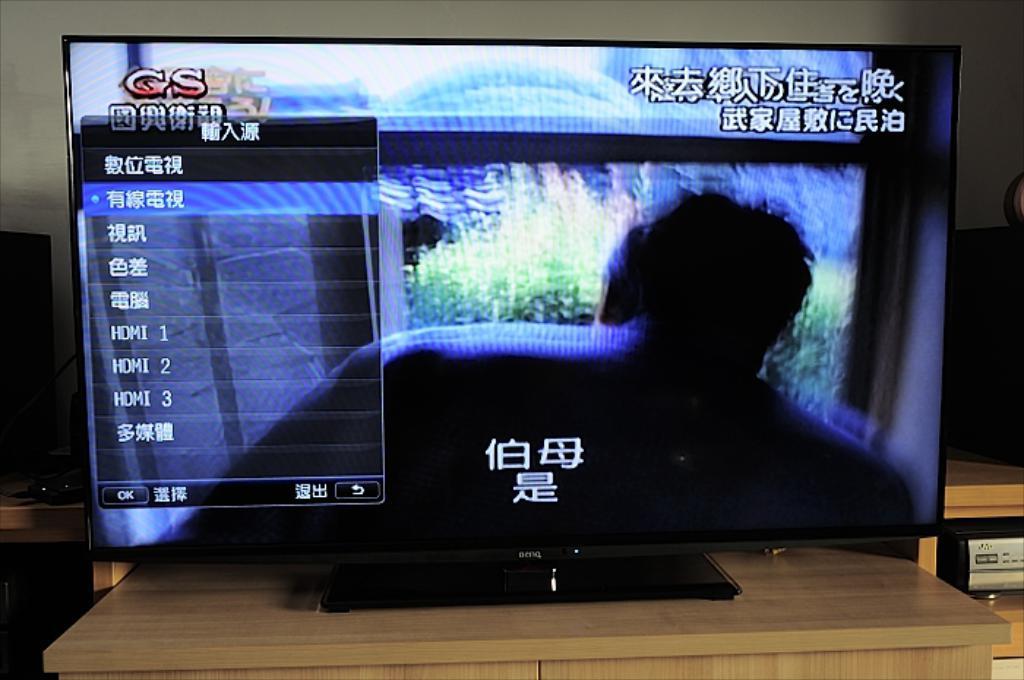How many hdmi slots are shown?
Provide a short and direct response. 3. 